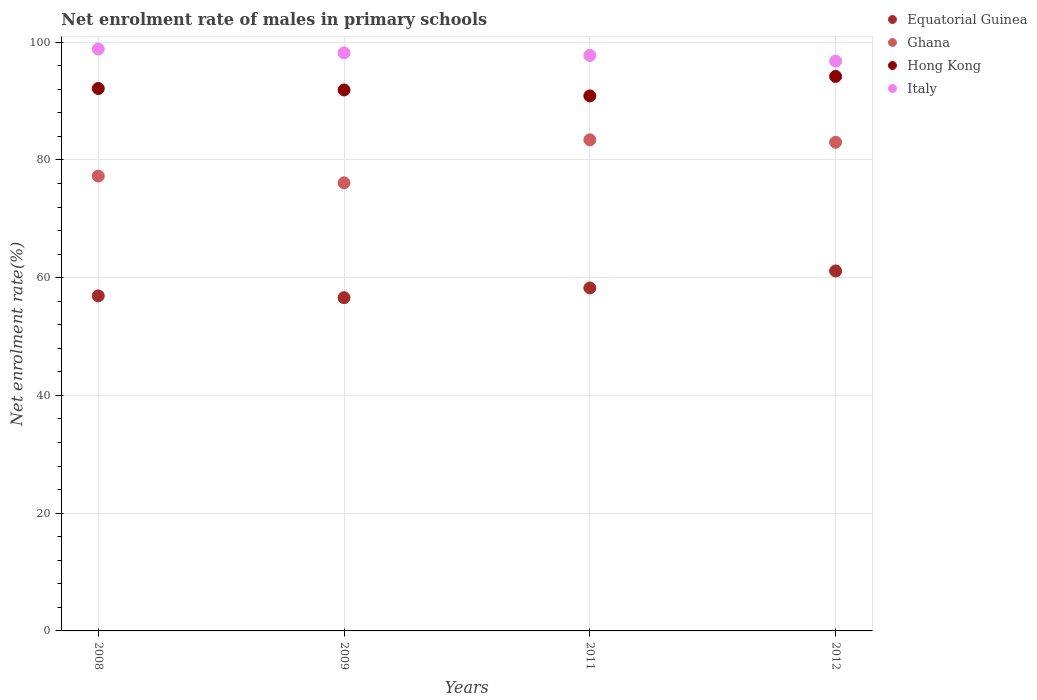Is the number of dotlines equal to the number of legend labels?
Provide a succinct answer. Yes. What is the net enrolment rate of males in primary schools in Italy in 2011?
Your response must be concise. 97.76. Across all years, what is the maximum net enrolment rate of males in primary schools in Hong Kong?
Offer a terse response. 94.2. Across all years, what is the minimum net enrolment rate of males in primary schools in Equatorial Guinea?
Your response must be concise. 56.61. In which year was the net enrolment rate of males in primary schools in Ghana minimum?
Provide a short and direct response. 2009. What is the total net enrolment rate of males in primary schools in Ghana in the graph?
Offer a very short reply. 319.81. What is the difference between the net enrolment rate of males in primary schools in Italy in 2009 and that in 2011?
Ensure brevity in your answer.  0.44. What is the difference between the net enrolment rate of males in primary schools in Hong Kong in 2012 and the net enrolment rate of males in primary schools in Ghana in 2009?
Offer a very short reply. 18.08. What is the average net enrolment rate of males in primary schools in Italy per year?
Offer a very short reply. 97.9. In the year 2012, what is the difference between the net enrolment rate of males in primary schools in Ghana and net enrolment rate of males in primary schools in Equatorial Guinea?
Keep it short and to the point. 21.86. What is the ratio of the net enrolment rate of males in primary schools in Italy in 2008 to that in 2009?
Keep it short and to the point. 1.01. Is the difference between the net enrolment rate of males in primary schools in Ghana in 2011 and 2012 greater than the difference between the net enrolment rate of males in primary schools in Equatorial Guinea in 2011 and 2012?
Your answer should be very brief. Yes. What is the difference between the highest and the second highest net enrolment rate of males in primary schools in Ghana?
Your response must be concise. 0.41. What is the difference between the highest and the lowest net enrolment rate of males in primary schools in Italy?
Keep it short and to the point. 2.05. Is the sum of the net enrolment rate of males in primary schools in Hong Kong in 2008 and 2009 greater than the maximum net enrolment rate of males in primary schools in Equatorial Guinea across all years?
Offer a terse response. Yes. Is it the case that in every year, the sum of the net enrolment rate of males in primary schools in Ghana and net enrolment rate of males in primary schools in Italy  is greater than the sum of net enrolment rate of males in primary schools in Equatorial Guinea and net enrolment rate of males in primary schools in Hong Kong?
Your answer should be compact. Yes. Is it the case that in every year, the sum of the net enrolment rate of males in primary schools in Ghana and net enrolment rate of males in primary schools in Equatorial Guinea  is greater than the net enrolment rate of males in primary schools in Hong Kong?
Provide a succinct answer. Yes. Is the net enrolment rate of males in primary schools in Italy strictly greater than the net enrolment rate of males in primary schools in Equatorial Guinea over the years?
Your response must be concise. Yes. How many years are there in the graph?
Provide a short and direct response. 4. Where does the legend appear in the graph?
Your answer should be compact. Top right. How many legend labels are there?
Offer a very short reply. 4. What is the title of the graph?
Keep it short and to the point. Net enrolment rate of males in primary schools. What is the label or title of the X-axis?
Your response must be concise. Years. What is the label or title of the Y-axis?
Your response must be concise. Net enrolment rate(%). What is the Net enrolment rate(%) of Equatorial Guinea in 2008?
Give a very brief answer. 56.92. What is the Net enrolment rate(%) of Ghana in 2008?
Provide a succinct answer. 77.27. What is the Net enrolment rate(%) of Hong Kong in 2008?
Provide a succinct answer. 92.14. What is the Net enrolment rate(%) of Italy in 2008?
Provide a short and direct response. 98.85. What is the Net enrolment rate(%) in Equatorial Guinea in 2009?
Offer a terse response. 56.61. What is the Net enrolment rate(%) in Ghana in 2009?
Provide a short and direct response. 76.12. What is the Net enrolment rate(%) of Hong Kong in 2009?
Keep it short and to the point. 91.89. What is the Net enrolment rate(%) in Italy in 2009?
Offer a terse response. 98.2. What is the Net enrolment rate(%) of Equatorial Guinea in 2011?
Offer a very short reply. 58.26. What is the Net enrolment rate(%) of Ghana in 2011?
Make the answer very short. 83.42. What is the Net enrolment rate(%) in Hong Kong in 2011?
Offer a very short reply. 90.89. What is the Net enrolment rate(%) in Italy in 2011?
Your answer should be compact. 97.76. What is the Net enrolment rate(%) in Equatorial Guinea in 2012?
Provide a succinct answer. 61.15. What is the Net enrolment rate(%) of Ghana in 2012?
Keep it short and to the point. 83.01. What is the Net enrolment rate(%) of Hong Kong in 2012?
Your answer should be very brief. 94.2. What is the Net enrolment rate(%) of Italy in 2012?
Your answer should be compact. 96.8. Across all years, what is the maximum Net enrolment rate(%) of Equatorial Guinea?
Offer a very short reply. 61.15. Across all years, what is the maximum Net enrolment rate(%) in Ghana?
Offer a terse response. 83.42. Across all years, what is the maximum Net enrolment rate(%) in Hong Kong?
Keep it short and to the point. 94.2. Across all years, what is the maximum Net enrolment rate(%) in Italy?
Your answer should be compact. 98.85. Across all years, what is the minimum Net enrolment rate(%) of Equatorial Guinea?
Offer a very short reply. 56.61. Across all years, what is the minimum Net enrolment rate(%) in Ghana?
Make the answer very short. 76.12. Across all years, what is the minimum Net enrolment rate(%) of Hong Kong?
Provide a short and direct response. 90.89. Across all years, what is the minimum Net enrolment rate(%) of Italy?
Offer a terse response. 96.8. What is the total Net enrolment rate(%) of Equatorial Guinea in the graph?
Provide a succinct answer. 232.94. What is the total Net enrolment rate(%) in Ghana in the graph?
Keep it short and to the point. 319.81. What is the total Net enrolment rate(%) of Hong Kong in the graph?
Provide a short and direct response. 369.13. What is the total Net enrolment rate(%) in Italy in the graph?
Your response must be concise. 391.61. What is the difference between the Net enrolment rate(%) of Equatorial Guinea in 2008 and that in 2009?
Provide a short and direct response. 0.31. What is the difference between the Net enrolment rate(%) in Ghana in 2008 and that in 2009?
Your answer should be compact. 1.15. What is the difference between the Net enrolment rate(%) of Hong Kong in 2008 and that in 2009?
Your response must be concise. 0.25. What is the difference between the Net enrolment rate(%) of Italy in 2008 and that in 2009?
Your answer should be very brief. 0.65. What is the difference between the Net enrolment rate(%) in Equatorial Guinea in 2008 and that in 2011?
Keep it short and to the point. -1.35. What is the difference between the Net enrolment rate(%) of Ghana in 2008 and that in 2011?
Provide a short and direct response. -6.15. What is the difference between the Net enrolment rate(%) in Hong Kong in 2008 and that in 2011?
Your answer should be compact. 1.25. What is the difference between the Net enrolment rate(%) in Italy in 2008 and that in 2011?
Keep it short and to the point. 1.09. What is the difference between the Net enrolment rate(%) in Equatorial Guinea in 2008 and that in 2012?
Your answer should be very brief. -4.23. What is the difference between the Net enrolment rate(%) of Ghana in 2008 and that in 2012?
Your answer should be compact. -5.74. What is the difference between the Net enrolment rate(%) of Hong Kong in 2008 and that in 2012?
Your response must be concise. -2.05. What is the difference between the Net enrolment rate(%) in Italy in 2008 and that in 2012?
Offer a very short reply. 2.05. What is the difference between the Net enrolment rate(%) of Equatorial Guinea in 2009 and that in 2011?
Your response must be concise. -1.65. What is the difference between the Net enrolment rate(%) in Ghana in 2009 and that in 2011?
Your answer should be very brief. -7.3. What is the difference between the Net enrolment rate(%) of Hong Kong in 2009 and that in 2011?
Your answer should be compact. 1. What is the difference between the Net enrolment rate(%) in Italy in 2009 and that in 2011?
Offer a very short reply. 0.44. What is the difference between the Net enrolment rate(%) in Equatorial Guinea in 2009 and that in 2012?
Provide a short and direct response. -4.54. What is the difference between the Net enrolment rate(%) of Ghana in 2009 and that in 2012?
Provide a short and direct response. -6.89. What is the difference between the Net enrolment rate(%) of Hong Kong in 2009 and that in 2012?
Offer a terse response. -2.31. What is the difference between the Net enrolment rate(%) of Italy in 2009 and that in 2012?
Your answer should be compact. 1.4. What is the difference between the Net enrolment rate(%) of Equatorial Guinea in 2011 and that in 2012?
Your answer should be very brief. -2.88. What is the difference between the Net enrolment rate(%) in Ghana in 2011 and that in 2012?
Your response must be concise. 0.41. What is the difference between the Net enrolment rate(%) in Hong Kong in 2011 and that in 2012?
Keep it short and to the point. -3.31. What is the difference between the Net enrolment rate(%) in Italy in 2011 and that in 2012?
Provide a short and direct response. 0.96. What is the difference between the Net enrolment rate(%) in Equatorial Guinea in 2008 and the Net enrolment rate(%) in Ghana in 2009?
Make the answer very short. -19.2. What is the difference between the Net enrolment rate(%) in Equatorial Guinea in 2008 and the Net enrolment rate(%) in Hong Kong in 2009?
Your answer should be very brief. -34.97. What is the difference between the Net enrolment rate(%) of Equatorial Guinea in 2008 and the Net enrolment rate(%) of Italy in 2009?
Keep it short and to the point. -41.28. What is the difference between the Net enrolment rate(%) in Ghana in 2008 and the Net enrolment rate(%) in Hong Kong in 2009?
Offer a very short reply. -14.63. What is the difference between the Net enrolment rate(%) in Ghana in 2008 and the Net enrolment rate(%) in Italy in 2009?
Give a very brief answer. -20.93. What is the difference between the Net enrolment rate(%) in Hong Kong in 2008 and the Net enrolment rate(%) in Italy in 2009?
Offer a very short reply. -6.05. What is the difference between the Net enrolment rate(%) in Equatorial Guinea in 2008 and the Net enrolment rate(%) in Ghana in 2011?
Offer a terse response. -26.5. What is the difference between the Net enrolment rate(%) in Equatorial Guinea in 2008 and the Net enrolment rate(%) in Hong Kong in 2011?
Offer a very short reply. -33.97. What is the difference between the Net enrolment rate(%) of Equatorial Guinea in 2008 and the Net enrolment rate(%) of Italy in 2011?
Keep it short and to the point. -40.84. What is the difference between the Net enrolment rate(%) in Ghana in 2008 and the Net enrolment rate(%) in Hong Kong in 2011?
Provide a succinct answer. -13.62. What is the difference between the Net enrolment rate(%) in Ghana in 2008 and the Net enrolment rate(%) in Italy in 2011?
Your answer should be very brief. -20.49. What is the difference between the Net enrolment rate(%) in Hong Kong in 2008 and the Net enrolment rate(%) in Italy in 2011?
Offer a terse response. -5.62. What is the difference between the Net enrolment rate(%) in Equatorial Guinea in 2008 and the Net enrolment rate(%) in Ghana in 2012?
Provide a short and direct response. -26.09. What is the difference between the Net enrolment rate(%) of Equatorial Guinea in 2008 and the Net enrolment rate(%) of Hong Kong in 2012?
Your answer should be compact. -37.28. What is the difference between the Net enrolment rate(%) of Equatorial Guinea in 2008 and the Net enrolment rate(%) of Italy in 2012?
Your answer should be compact. -39.88. What is the difference between the Net enrolment rate(%) of Ghana in 2008 and the Net enrolment rate(%) of Hong Kong in 2012?
Provide a short and direct response. -16.93. What is the difference between the Net enrolment rate(%) of Ghana in 2008 and the Net enrolment rate(%) of Italy in 2012?
Your answer should be very brief. -19.53. What is the difference between the Net enrolment rate(%) in Hong Kong in 2008 and the Net enrolment rate(%) in Italy in 2012?
Make the answer very short. -4.66. What is the difference between the Net enrolment rate(%) in Equatorial Guinea in 2009 and the Net enrolment rate(%) in Ghana in 2011?
Provide a succinct answer. -26.81. What is the difference between the Net enrolment rate(%) in Equatorial Guinea in 2009 and the Net enrolment rate(%) in Hong Kong in 2011?
Your answer should be compact. -34.28. What is the difference between the Net enrolment rate(%) of Equatorial Guinea in 2009 and the Net enrolment rate(%) of Italy in 2011?
Make the answer very short. -41.15. What is the difference between the Net enrolment rate(%) of Ghana in 2009 and the Net enrolment rate(%) of Hong Kong in 2011?
Provide a short and direct response. -14.77. What is the difference between the Net enrolment rate(%) of Ghana in 2009 and the Net enrolment rate(%) of Italy in 2011?
Offer a very short reply. -21.64. What is the difference between the Net enrolment rate(%) in Hong Kong in 2009 and the Net enrolment rate(%) in Italy in 2011?
Give a very brief answer. -5.87. What is the difference between the Net enrolment rate(%) of Equatorial Guinea in 2009 and the Net enrolment rate(%) of Ghana in 2012?
Provide a succinct answer. -26.39. What is the difference between the Net enrolment rate(%) of Equatorial Guinea in 2009 and the Net enrolment rate(%) of Hong Kong in 2012?
Your answer should be compact. -37.59. What is the difference between the Net enrolment rate(%) of Equatorial Guinea in 2009 and the Net enrolment rate(%) of Italy in 2012?
Provide a succinct answer. -40.19. What is the difference between the Net enrolment rate(%) of Ghana in 2009 and the Net enrolment rate(%) of Hong Kong in 2012?
Provide a succinct answer. -18.08. What is the difference between the Net enrolment rate(%) of Ghana in 2009 and the Net enrolment rate(%) of Italy in 2012?
Ensure brevity in your answer.  -20.68. What is the difference between the Net enrolment rate(%) of Hong Kong in 2009 and the Net enrolment rate(%) of Italy in 2012?
Keep it short and to the point. -4.91. What is the difference between the Net enrolment rate(%) in Equatorial Guinea in 2011 and the Net enrolment rate(%) in Ghana in 2012?
Make the answer very short. -24.74. What is the difference between the Net enrolment rate(%) of Equatorial Guinea in 2011 and the Net enrolment rate(%) of Hong Kong in 2012?
Your answer should be compact. -35.94. What is the difference between the Net enrolment rate(%) in Equatorial Guinea in 2011 and the Net enrolment rate(%) in Italy in 2012?
Provide a succinct answer. -38.54. What is the difference between the Net enrolment rate(%) in Ghana in 2011 and the Net enrolment rate(%) in Hong Kong in 2012?
Ensure brevity in your answer.  -10.78. What is the difference between the Net enrolment rate(%) in Ghana in 2011 and the Net enrolment rate(%) in Italy in 2012?
Give a very brief answer. -13.38. What is the difference between the Net enrolment rate(%) in Hong Kong in 2011 and the Net enrolment rate(%) in Italy in 2012?
Ensure brevity in your answer.  -5.91. What is the average Net enrolment rate(%) of Equatorial Guinea per year?
Give a very brief answer. 58.24. What is the average Net enrolment rate(%) of Ghana per year?
Provide a succinct answer. 79.95. What is the average Net enrolment rate(%) of Hong Kong per year?
Your response must be concise. 92.28. What is the average Net enrolment rate(%) of Italy per year?
Ensure brevity in your answer.  97.9. In the year 2008, what is the difference between the Net enrolment rate(%) of Equatorial Guinea and Net enrolment rate(%) of Ghana?
Ensure brevity in your answer.  -20.35. In the year 2008, what is the difference between the Net enrolment rate(%) of Equatorial Guinea and Net enrolment rate(%) of Hong Kong?
Your response must be concise. -35.23. In the year 2008, what is the difference between the Net enrolment rate(%) of Equatorial Guinea and Net enrolment rate(%) of Italy?
Offer a very short reply. -41.93. In the year 2008, what is the difference between the Net enrolment rate(%) in Ghana and Net enrolment rate(%) in Hong Kong?
Provide a short and direct response. -14.88. In the year 2008, what is the difference between the Net enrolment rate(%) in Ghana and Net enrolment rate(%) in Italy?
Make the answer very short. -21.58. In the year 2008, what is the difference between the Net enrolment rate(%) of Hong Kong and Net enrolment rate(%) of Italy?
Make the answer very short. -6.71. In the year 2009, what is the difference between the Net enrolment rate(%) in Equatorial Guinea and Net enrolment rate(%) in Ghana?
Ensure brevity in your answer.  -19.5. In the year 2009, what is the difference between the Net enrolment rate(%) in Equatorial Guinea and Net enrolment rate(%) in Hong Kong?
Your answer should be very brief. -35.28. In the year 2009, what is the difference between the Net enrolment rate(%) of Equatorial Guinea and Net enrolment rate(%) of Italy?
Make the answer very short. -41.59. In the year 2009, what is the difference between the Net enrolment rate(%) of Ghana and Net enrolment rate(%) of Hong Kong?
Offer a very short reply. -15.78. In the year 2009, what is the difference between the Net enrolment rate(%) of Ghana and Net enrolment rate(%) of Italy?
Provide a succinct answer. -22.08. In the year 2009, what is the difference between the Net enrolment rate(%) of Hong Kong and Net enrolment rate(%) of Italy?
Your answer should be compact. -6.3. In the year 2011, what is the difference between the Net enrolment rate(%) in Equatorial Guinea and Net enrolment rate(%) in Ghana?
Your response must be concise. -25.16. In the year 2011, what is the difference between the Net enrolment rate(%) in Equatorial Guinea and Net enrolment rate(%) in Hong Kong?
Offer a very short reply. -32.63. In the year 2011, what is the difference between the Net enrolment rate(%) in Equatorial Guinea and Net enrolment rate(%) in Italy?
Give a very brief answer. -39.5. In the year 2011, what is the difference between the Net enrolment rate(%) in Ghana and Net enrolment rate(%) in Hong Kong?
Your response must be concise. -7.47. In the year 2011, what is the difference between the Net enrolment rate(%) of Ghana and Net enrolment rate(%) of Italy?
Offer a very short reply. -14.34. In the year 2011, what is the difference between the Net enrolment rate(%) of Hong Kong and Net enrolment rate(%) of Italy?
Your response must be concise. -6.87. In the year 2012, what is the difference between the Net enrolment rate(%) of Equatorial Guinea and Net enrolment rate(%) of Ghana?
Ensure brevity in your answer.  -21.86. In the year 2012, what is the difference between the Net enrolment rate(%) of Equatorial Guinea and Net enrolment rate(%) of Hong Kong?
Keep it short and to the point. -33.05. In the year 2012, what is the difference between the Net enrolment rate(%) in Equatorial Guinea and Net enrolment rate(%) in Italy?
Your answer should be very brief. -35.65. In the year 2012, what is the difference between the Net enrolment rate(%) in Ghana and Net enrolment rate(%) in Hong Kong?
Give a very brief answer. -11.19. In the year 2012, what is the difference between the Net enrolment rate(%) in Ghana and Net enrolment rate(%) in Italy?
Your answer should be compact. -13.79. In the year 2012, what is the difference between the Net enrolment rate(%) of Hong Kong and Net enrolment rate(%) of Italy?
Offer a very short reply. -2.6. What is the ratio of the Net enrolment rate(%) of Equatorial Guinea in 2008 to that in 2009?
Your answer should be compact. 1.01. What is the ratio of the Net enrolment rate(%) of Ghana in 2008 to that in 2009?
Keep it short and to the point. 1.02. What is the ratio of the Net enrolment rate(%) in Italy in 2008 to that in 2009?
Your answer should be compact. 1.01. What is the ratio of the Net enrolment rate(%) of Equatorial Guinea in 2008 to that in 2011?
Your response must be concise. 0.98. What is the ratio of the Net enrolment rate(%) of Ghana in 2008 to that in 2011?
Your response must be concise. 0.93. What is the ratio of the Net enrolment rate(%) in Hong Kong in 2008 to that in 2011?
Offer a terse response. 1.01. What is the ratio of the Net enrolment rate(%) in Italy in 2008 to that in 2011?
Ensure brevity in your answer.  1.01. What is the ratio of the Net enrolment rate(%) of Equatorial Guinea in 2008 to that in 2012?
Ensure brevity in your answer.  0.93. What is the ratio of the Net enrolment rate(%) of Ghana in 2008 to that in 2012?
Keep it short and to the point. 0.93. What is the ratio of the Net enrolment rate(%) of Hong Kong in 2008 to that in 2012?
Give a very brief answer. 0.98. What is the ratio of the Net enrolment rate(%) in Italy in 2008 to that in 2012?
Offer a terse response. 1.02. What is the ratio of the Net enrolment rate(%) of Equatorial Guinea in 2009 to that in 2011?
Keep it short and to the point. 0.97. What is the ratio of the Net enrolment rate(%) in Ghana in 2009 to that in 2011?
Offer a terse response. 0.91. What is the ratio of the Net enrolment rate(%) of Hong Kong in 2009 to that in 2011?
Make the answer very short. 1.01. What is the ratio of the Net enrolment rate(%) in Italy in 2009 to that in 2011?
Offer a terse response. 1. What is the ratio of the Net enrolment rate(%) of Equatorial Guinea in 2009 to that in 2012?
Provide a succinct answer. 0.93. What is the ratio of the Net enrolment rate(%) of Ghana in 2009 to that in 2012?
Keep it short and to the point. 0.92. What is the ratio of the Net enrolment rate(%) in Hong Kong in 2009 to that in 2012?
Make the answer very short. 0.98. What is the ratio of the Net enrolment rate(%) in Italy in 2009 to that in 2012?
Keep it short and to the point. 1.01. What is the ratio of the Net enrolment rate(%) of Equatorial Guinea in 2011 to that in 2012?
Keep it short and to the point. 0.95. What is the ratio of the Net enrolment rate(%) of Hong Kong in 2011 to that in 2012?
Offer a very short reply. 0.96. What is the ratio of the Net enrolment rate(%) of Italy in 2011 to that in 2012?
Provide a succinct answer. 1.01. What is the difference between the highest and the second highest Net enrolment rate(%) of Equatorial Guinea?
Ensure brevity in your answer.  2.88. What is the difference between the highest and the second highest Net enrolment rate(%) in Ghana?
Offer a very short reply. 0.41. What is the difference between the highest and the second highest Net enrolment rate(%) in Hong Kong?
Offer a terse response. 2.05. What is the difference between the highest and the second highest Net enrolment rate(%) of Italy?
Keep it short and to the point. 0.65. What is the difference between the highest and the lowest Net enrolment rate(%) of Equatorial Guinea?
Give a very brief answer. 4.54. What is the difference between the highest and the lowest Net enrolment rate(%) in Ghana?
Provide a short and direct response. 7.3. What is the difference between the highest and the lowest Net enrolment rate(%) in Hong Kong?
Your answer should be compact. 3.31. What is the difference between the highest and the lowest Net enrolment rate(%) in Italy?
Your answer should be compact. 2.05. 